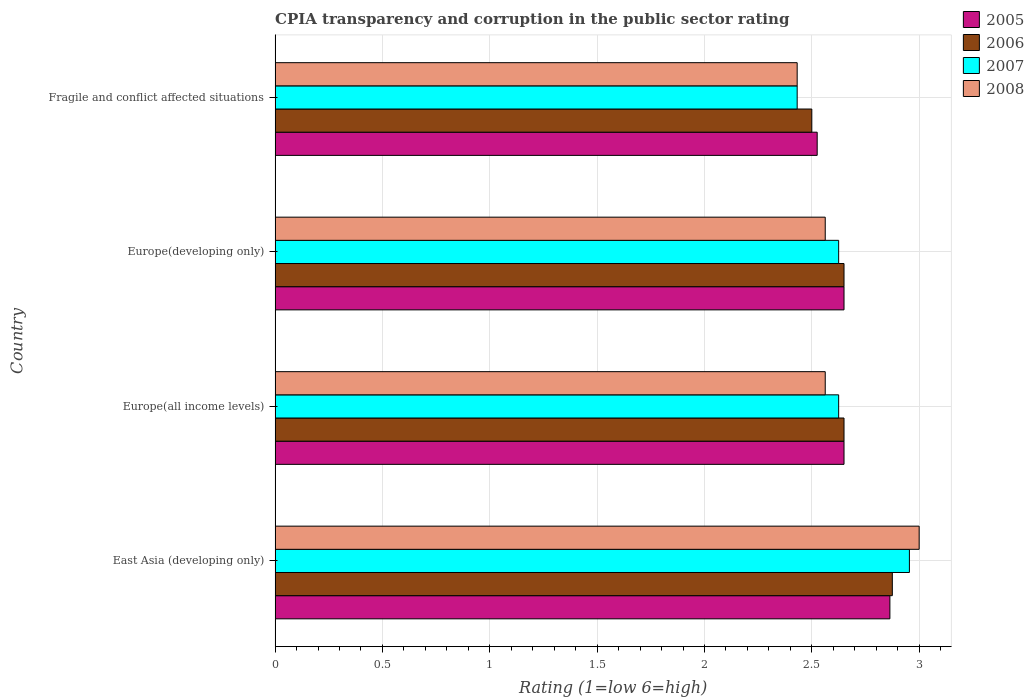How many groups of bars are there?
Ensure brevity in your answer.  4. How many bars are there on the 4th tick from the top?
Make the answer very short. 4. What is the label of the 1st group of bars from the top?
Give a very brief answer. Fragile and conflict affected situations. What is the CPIA rating in 2008 in East Asia (developing only)?
Make the answer very short. 3. Across all countries, what is the maximum CPIA rating in 2006?
Keep it short and to the point. 2.88. Across all countries, what is the minimum CPIA rating in 2007?
Make the answer very short. 2.43. In which country was the CPIA rating in 2008 maximum?
Your response must be concise. East Asia (developing only). In which country was the CPIA rating in 2005 minimum?
Provide a short and direct response. Fragile and conflict affected situations. What is the total CPIA rating in 2006 in the graph?
Provide a succinct answer. 10.68. What is the difference between the CPIA rating in 2008 in Europe(developing only) and that in Fragile and conflict affected situations?
Provide a short and direct response. 0.13. What is the difference between the CPIA rating in 2008 in Europe(developing only) and the CPIA rating in 2005 in East Asia (developing only)?
Provide a short and direct response. -0.3. What is the average CPIA rating in 2006 per country?
Your response must be concise. 2.67. What is the ratio of the CPIA rating in 2007 in Europe(developing only) to that in Fragile and conflict affected situations?
Your answer should be compact. 1.08. Is the CPIA rating in 2005 in Europe(all income levels) less than that in Fragile and conflict affected situations?
Give a very brief answer. No. What is the difference between the highest and the second highest CPIA rating in 2008?
Provide a short and direct response. 0.44. In how many countries, is the CPIA rating in 2006 greater than the average CPIA rating in 2006 taken over all countries?
Your answer should be compact. 1. Is it the case that in every country, the sum of the CPIA rating in 2007 and CPIA rating in 2006 is greater than the sum of CPIA rating in 2005 and CPIA rating in 2008?
Provide a short and direct response. No. What does the 3rd bar from the top in Fragile and conflict affected situations represents?
Provide a succinct answer. 2006. How many bars are there?
Your answer should be compact. 16. How many countries are there in the graph?
Offer a terse response. 4. Are the values on the major ticks of X-axis written in scientific E-notation?
Make the answer very short. No. Does the graph contain grids?
Offer a terse response. Yes. How many legend labels are there?
Your answer should be very brief. 4. How are the legend labels stacked?
Provide a succinct answer. Vertical. What is the title of the graph?
Make the answer very short. CPIA transparency and corruption in the public sector rating. Does "2014" appear as one of the legend labels in the graph?
Your answer should be compact. No. What is the label or title of the X-axis?
Your response must be concise. Rating (1=low 6=high). What is the Rating (1=low 6=high) of 2005 in East Asia (developing only)?
Your answer should be very brief. 2.86. What is the Rating (1=low 6=high) of 2006 in East Asia (developing only)?
Provide a succinct answer. 2.88. What is the Rating (1=low 6=high) in 2007 in East Asia (developing only)?
Your response must be concise. 2.95. What is the Rating (1=low 6=high) of 2008 in East Asia (developing only)?
Ensure brevity in your answer.  3. What is the Rating (1=low 6=high) in 2005 in Europe(all income levels)?
Make the answer very short. 2.65. What is the Rating (1=low 6=high) of 2006 in Europe(all income levels)?
Your answer should be compact. 2.65. What is the Rating (1=low 6=high) of 2007 in Europe(all income levels)?
Your answer should be compact. 2.62. What is the Rating (1=low 6=high) of 2008 in Europe(all income levels)?
Your response must be concise. 2.56. What is the Rating (1=low 6=high) in 2005 in Europe(developing only)?
Give a very brief answer. 2.65. What is the Rating (1=low 6=high) in 2006 in Europe(developing only)?
Provide a succinct answer. 2.65. What is the Rating (1=low 6=high) in 2007 in Europe(developing only)?
Offer a terse response. 2.62. What is the Rating (1=low 6=high) of 2008 in Europe(developing only)?
Your response must be concise. 2.56. What is the Rating (1=low 6=high) in 2005 in Fragile and conflict affected situations?
Offer a very short reply. 2.52. What is the Rating (1=low 6=high) of 2006 in Fragile and conflict affected situations?
Your response must be concise. 2.5. What is the Rating (1=low 6=high) of 2007 in Fragile and conflict affected situations?
Offer a terse response. 2.43. What is the Rating (1=low 6=high) of 2008 in Fragile and conflict affected situations?
Provide a short and direct response. 2.43. Across all countries, what is the maximum Rating (1=low 6=high) in 2005?
Provide a short and direct response. 2.86. Across all countries, what is the maximum Rating (1=low 6=high) in 2006?
Your response must be concise. 2.88. Across all countries, what is the maximum Rating (1=low 6=high) in 2007?
Your response must be concise. 2.95. Across all countries, what is the minimum Rating (1=low 6=high) of 2005?
Provide a succinct answer. 2.52. Across all countries, what is the minimum Rating (1=low 6=high) of 2006?
Offer a very short reply. 2.5. Across all countries, what is the minimum Rating (1=low 6=high) in 2007?
Make the answer very short. 2.43. Across all countries, what is the minimum Rating (1=low 6=high) in 2008?
Provide a short and direct response. 2.43. What is the total Rating (1=low 6=high) of 2005 in the graph?
Your answer should be compact. 10.69. What is the total Rating (1=low 6=high) of 2006 in the graph?
Ensure brevity in your answer.  10.68. What is the total Rating (1=low 6=high) in 2007 in the graph?
Your answer should be compact. 10.64. What is the total Rating (1=low 6=high) of 2008 in the graph?
Make the answer very short. 10.56. What is the difference between the Rating (1=low 6=high) of 2005 in East Asia (developing only) and that in Europe(all income levels)?
Ensure brevity in your answer.  0.21. What is the difference between the Rating (1=low 6=high) of 2006 in East Asia (developing only) and that in Europe(all income levels)?
Keep it short and to the point. 0.23. What is the difference between the Rating (1=low 6=high) in 2007 in East Asia (developing only) and that in Europe(all income levels)?
Your answer should be very brief. 0.33. What is the difference between the Rating (1=low 6=high) in 2008 in East Asia (developing only) and that in Europe(all income levels)?
Your response must be concise. 0.44. What is the difference between the Rating (1=low 6=high) of 2005 in East Asia (developing only) and that in Europe(developing only)?
Provide a succinct answer. 0.21. What is the difference between the Rating (1=low 6=high) of 2006 in East Asia (developing only) and that in Europe(developing only)?
Offer a very short reply. 0.23. What is the difference between the Rating (1=low 6=high) in 2007 in East Asia (developing only) and that in Europe(developing only)?
Provide a succinct answer. 0.33. What is the difference between the Rating (1=low 6=high) of 2008 in East Asia (developing only) and that in Europe(developing only)?
Your response must be concise. 0.44. What is the difference between the Rating (1=low 6=high) of 2005 in East Asia (developing only) and that in Fragile and conflict affected situations?
Make the answer very short. 0.34. What is the difference between the Rating (1=low 6=high) of 2006 in East Asia (developing only) and that in Fragile and conflict affected situations?
Keep it short and to the point. 0.38. What is the difference between the Rating (1=low 6=high) in 2007 in East Asia (developing only) and that in Fragile and conflict affected situations?
Keep it short and to the point. 0.52. What is the difference between the Rating (1=low 6=high) of 2008 in East Asia (developing only) and that in Fragile and conflict affected situations?
Your response must be concise. 0.57. What is the difference between the Rating (1=low 6=high) of 2005 in Europe(all income levels) and that in Europe(developing only)?
Ensure brevity in your answer.  0. What is the difference between the Rating (1=low 6=high) of 2008 in Europe(all income levels) and that in Europe(developing only)?
Make the answer very short. 0. What is the difference between the Rating (1=low 6=high) in 2007 in Europe(all income levels) and that in Fragile and conflict affected situations?
Offer a very short reply. 0.19. What is the difference between the Rating (1=low 6=high) of 2008 in Europe(all income levels) and that in Fragile and conflict affected situations?
Give a very brief answer. 0.13. What is the difference between the Rating (1=low 6=high) in 2007 in Europe(developing only) and that in Fragile and conflict affected situations?
Your response must be concise. 0.19. What is the difference between the Rating (1=low 6=high) in 2008 in Europe(developing only) and that in Fragile and conflict affected situations?
Provide a succinct answer. 0.13. What is the difference between the Rating (1=low 6=high) of 2005 in East Asia (developing only) and the Rating (1=low 6=high) of 2006 in Europe(all income levels)?
Provide a short and direct response. 0.21. What is the difference between the Rating (1=low 6=high) of 2005 in East Asia (developing only) and the Rating (1=low 6=high) of 2007 in Europe(all income levels)?
Give a very brief answer. 0.24. What is the difference between the Rating (1=low 6=high) of 2005 in East Asia (developing only) and the Rating (1=low 6=high) of 2008 in Europe(all income levels)?
Provide a succinct answer. 0.3. What is the difference between the Rating (1=low 6=high) of 2006 in East Asia (developing only) and the Rating (1=low 6=high) of 2008 in Europe(all income levels)?
Your response must be concise. 0.31. What is the difference between the Rating (1=low 6=high) in 2007 in East Asia (developing only) and the Rating (1=low 6=high) in 2008 in Europe(all income levels)?
Give a very brief answer. 0.39. What is the difference between the Rating (1=low 6=high) of 2005 in East Asia (developing only) and the Rating (1=low 6=high) of 2006 in Europe(developing only)?
Your answer should be very brief. 0.21. What is the difference between the Rating (1=low 6=high) of 2005 in East Asia (developing only) and the Rating (1=low 6=high) of 2007 in Europe(developing only)?
Your response must be concise. 0.24. What is the difference between the Rating (1=low 6=high) in 2005 in East Asia (developing only) and the Rating (1=low 6=high) in 2008 in Europe(developing only)?
Make the answer very short. 0.3. What is the difference between the Rating (1=low 6=high) of 2006 in East Asia (developing only) and the Rating (1=low 6=high) of 2008 in Europe(developing only)?
Offer a terse response. 0.31. What is the difference between the Rating (1=low 6=high) of 2007 in East Asia (developing only) and the Rating (1=low 6=high) of 2008 in Europe(developing only)?
Your response must be concise. 0.39. What is the difference between the Rating (1=low 6=high) in 2005 in East Asia (developing only) and the Rating (1=low 6=high) in 2006 in Fragile and conflict affected situations?
Your answer should be very brief. 0.36. What is the difference between the Rating (1=low 6=high) of 2005 in East Asia (developing only) and the Rating (1=low 6=high) of 2007 in Fragile and conflict affected situations?
Keep it short and to the point. 0.43. What is the difference between the Rating (1=low 6=high) of 2005 in East Asia (developing only) and the Rating (1=low 6=high) of 2008 in Fragile and conflict affected situations?
Your answer should be very brief. 0.43. What is the difference between the Rating (1=low 6=high) in 2006 in East Asia (developing only) and the Rating (1=low 6=high) in 2007 in Fragile and conflict affected situations?
Provide a succinct answer. 0.44. What is the difference between the Rating (1=low 6=high) of 2006 in East Asia (developing only) and the Rating (1=low 6=high) of 2008 in Fragile and conflict affected situations?
Provide a short and direct response. 0.44. What is the difference between the Rating (1=low 6=high) of 2007 in East Asia (developing only) and the Rating (1=low 6=high) of 2008 in Fragile and conflict affected situations?
Your answer should be very brief. 0.52. What is the difference between the Rating (1=low 6=high) in 2005 in Europe(all income levels) and the Rating (1=low 6=high) in 2007 in Europe(developing only)?
Your answer should be compact. 0.03. What is the difference between the Rating (1=low 6=high) of 2005 in Europe(all income levels) and the Rating (1=low 6=high) of 2008 in Europe(developing only)?
Your answer should be compact. 0.09. What is the difference between the Rating (1=low 6=high) in 2006 in Europe(all income levels) and the Rating (1=low 6=high) in 2007 in Europe(developing only)?
Offer a terse response. 0.03. What is the difference between the Rating (1=low 6=high) of 2006 in Europe(all income levels) and the Rating (1=low 6=high) of 2008 in Europe(developing only)?
Keep it short and to the point. 0.09. What is the difference between the Rating (1=low 6=high) in 2007 in Europe(all income levels) and the Rating (1=low 6=high) in 2008 in Europe(developing only)?
Your response must be concise. 0.06. What is the difference between the Rating (1=low 6=high) in 2005 in Europe(all income levels) and the Rating (1=low 6=high) in 2006 in Fragile and conflict affected situations?
Offer a terse response. 0.15. What is the difference between the Rating (1=low 6=high) in 2005 in Europe(all income levels) and the Rating (1=low 6=high) in 2007 in Fragile and conflict affected situations?
Provide a short and direct response. 0.22. What is the difference between the Rating (1=low 6=high) in 2005 in Europe(all income levels) and the Rating (1=low 6=high) in 2008 in Fragile and conflict affected situations?
Give a very brief answer. 0.22. What is the difference between the Rating (1=low 6=high) in 2006 in Europe(all income levels) and the Rating (1=low 6=high) in 2007 in Fragile and conflict affected situations?
Offer a terse response. 0.22. What is the difference between the Rating (1=low 6=high) in 2006 in Europe(all income levels) and the Rating (1=low 6=high) in 2008 in Fragile and conflict affected situations?
Your answer should be compact. 0.22. What is the difference between the Rating (1=low 6=high) of 2007 in Europe(all income levels) and the Rating (1=low 6=high) of 2008 in Fragile and conflict affected situations?
Your answer should be compact. 0.19. What is the difference between the Rating (1=low 6=high) in 2005 in Europe(developing only) and the Rating (1=low 6=high) in 2006 in Fragile and conflict affected situations?
Your answer should be compact. 0.15. What is the difference between the Rating (1=low 6=high) of 2005 in Europe(developing only) and the Rating (1=low 6=high) of 2007 in Fragile and conflict affected situations?
Ensure brevity in your answer.  0.22. What is the difference between the Rating (1=low 6=high) of 2005 in Europe(developing only) and the Rating (1=low 6=high) of 2008 in Fragile and conflict affected situations?
Provide a succinct answer. 0.22. What is the difference between the Rating (1=low 6=high) in 2006 in Europe(developing only) and the Rating (1=low 6=high) in 2007 in Fragile and conflict affected situations?
Ensure brevity in your answer.  0.22. What is the difference between the Rating (1=low 6=high) of 2006 in Europe(developing only) and the Rating (1=low 6=high) of 2008 in Fragile and conflict affected situations?
Give a very brief answer. 0.22. What is the difference between the Rating (1=low 6=high) in 2007 in Europe(developing only) and the Rating (1=low 6=high) in 2008 in Fragile and conflict affected situations?
Your answer should be very brief. 0.19. What is the average Rating (1=low 6=high) of 2005 per country?
Provide a short and direct response. 2.67. What is the average Rating (1=low 6=high) in 2006 per country?
Offer a very short reply. 2.67. What is the average Rating (1=low 6=high) of 2007 per country?
Offer a terse response. 2.66. What is the average Rating (1=low 6=high) of 2008 per country?
Provide a succinct answer. 2.64. What is the difference between the Rating (1=low 6=high) in 2005 and Rating (1=low 6=high) in 2006 in East Asia (developing only)?
Ensure brevity in your answer.  -0.01. What is the difference between the Rating (1=low 6=high) in 2005 and Rating (1=low 6=high) in 2007 in East Asia (developing only)?
Your response must be concise. -0.09. What is the difference between the Rating (1=low 6=high) in 2005 and Rating (1=low 6=high) in 2008 in East Asia (developing only)?
Make the answer very short. -0.14. What is the difference between the Rating (1=low 6=high) in 2006 and Rating (1=low 6=high) in 2007 in East Asia (developing only)?
Make the answer very short. -0.08. What is the difference between the Rating (1=low 6=high) of 2006 and Rating (1=low 6=high) of 2008 in East Asia (developing only)?
Offer a terse response. -0.12. What is the difference between the Rating (1=low 6=high) in 2007 and Rating (1=low 6=high) in 2008 in East Asia (developing only)?
Offer a terse response. -0.05. What is the difference between the Rating (1=low 6=high) in 2005 and Rating (1=low 6=high) in 2006 in Europe(all income levels)?
Offer a terse response. 0. What is the difference between the Rating (1=low 6=high) of 2005 and Rating (1=low 6=high) of 2007 in Europe(all income levels)?
Offer a very short reply. 0.03. What is the difference between the Rating (1=low 6=high) in 2005 and Rating (1=low 6=high) in 2008 in Europe(all income levels)?
Provide a short and direct response. 0.09. What is the difference between the Rating (1=low 6=high) of 2006 and Rating (1=low 6=high) of 2007 in Europe(all income levels)?
Provide a short and direct response. 0.03. What is the difference between the Rating (1=low 6=high) of 2006 and Rating (1=low 6=high) of 2008 in Europe(all income levels)?
Provide a succinct answer. 0.09. What is the difference between the Rating (1=low 6=high) in 2007 and Rating (1=low 6=high) in 2008 in Europe(all income levels)?
Your answer should be very brief. 0.06. What is the difference between the Rating (1=low 6=high) in 2005 and Rating (1=low 6=high) in 2007 in Europe(developing only)?
Offer a very short reply. 0.03. What is the difference between the Rating (1=low 6=high) of 2005 and Rating (1=low 6=high) of 2008 in Europe(developing only)?
Ensure brevity in your answer.  0.09. What is the difference between the Rating (1=low 6=high) of 2006 and Rating (1=low 6=high) of 2007 in Europe(developing only)?
Your response must be concise. 0.03. What is the difference between the Rating (1=low 6=high) of 2006 and Rating (1=low 6=high) of 2008 in Europe(developing only)?
Offer a very short reply. 0.09. What is the difference between the Rating (1=low 6=high) in 2007 and Rating (1=low 6=high) in 2008 in Europe(developing only)?
Make the answer very short. 0.06. What is the difference between the Rating (1=low 6=high) in 2005 and Rating (1=low 6=high) in 2006 in Fragile and conflict affected situations?
Ensure brevity in your answer.  0.03. What is the difference between the Rating (1=low 6=high) of 2005 and Rating (1=low 6=high) of 2007 in Fragile and conflict affected situations?
Offer a terse response. 0.09. What is the difference between the Rating (1=low 6=high) in 2005 and Rating (1=low 6=high) in 2008 in Fragile and conflict affected situations?
Provide a short and direct response. 0.09. What is the difference between the Rating (1=low 6=high) in 2006 and Rating (1=low 6=high) in 2007 in Fragile and conflict affected situations?
Give a very brief answer. 0.07. What is the difference between the Rating (1=low 6=high) of 2006 and Rating (1=low 6=high) of 2008 in Fragile and conflict affected situations?
Make the answer very short. 0.07. What is the difference between the Rating (1=low 6=high) of 2007 and Rating (1=low 6=high) of 2008 in Fragile and conflict affected situations?
Keep it short and to the point. 0. What is the ratio of the Rating (1=low 6=high) in 2005 in East Asia (developing only) to that in Europe(all income levels)?
Make the answer very short. 1.08. What is the ratio of the Rating (1=low 6=high) in 2006 in East Asia (developing only) to that in Europe(all income levels)?
Offer a very short reply. 1.08. What is the ratio of the Rating (1=low 6=high) of 2007 in East Asia (developing only) to that in Europe(all income levels)?
Your answer should be compact. 1.13. What is the ratio of the Rating (1=low 6=high) of 2008 in East Asia (developing only) to that in Europe(all income levels)?
Your response must be concise. 1.17. What is the ratio of the Rating (1=low 6=high) in 2005 in East Asia (developing only) to that in Europe(developing only)?
Make the answer very short. 1.08. What is the ratio of the Rating (1=low 6=high) of 2006 in East Asia (developing only) to that in Europe(developing only)?
Keep it short and to the point. 1.08. What is the ratio of the Rating (1=low 6=high) in 2007 in East Asia (developing only) to that in Europe(developing only)?
Make the answer very short. 1.13. What is the ratio of the Rating (1=low 6=high) of 2008 in East Asia (developing only) to that in Europe(developing only)?
Ensure brevity in your answer.  1.17. What is the ratio of the Rating (1=low 6=high) in 2005 in East Asia (developing only) to that in Fragile and conflict affected situations?
Offer a terse response. 1.13. What is the ratio of the Rating (1=low 6=high) of 2006 in East Asia (developing only) to that in Fragile and conflict affected situations?
Offer a very short reply. 1.15. What is the ratio of the Rating (1=low 6=high) in 2007 in East Asia (developing only) to that in Fragile and conflict affected situations?
Offer a terse response. 1.22. What is the ratio of the Rating (1=low 6=high) of 2008 in East Asia (developing only) to that in Fragile and conflict affected situations?
Keep it short and to the point. 1.23. What is the ratio of the Rating (1=low 6=high) in 2005 in Europe(all income levels) to that in Fragile and conflict affected situations?
Provide a succinct answer. 1.05. What is the ratio of the Rating (1=low 6=high) in 2006 in Europe(all income levels) to that in Fragile and conflict affected situations?
Your answer should be compact. 1.06. What is the ratio of the Rating (1=low 6=high) of 2007 in Europe(all income levels) to that in Fragile and conflict affected situations?
Give a very brief answer. 1.08. What is the ratio of the Rating (1=low 6=high) of 2008 in Europe(all income levels) to that in Fragile and conflict affected situations?
Ensure brevity in your answer.  1.05. What is the ratio of the Rating (1=low 6=high) of 2005 in Europe(developing only) to that in Fragile and conflict affected situations?
Make the answer very short. 1.05. What is the ratio of the Rating (1=low 6=high) of 2006 in Europe(developing only) to that in Fragile and conflict affected situations?
Your response must be concise. 1.06. What is the ratio of the Rating (1=low 6=high) in 2007 in Europe(developing only) to that in Fragile and conflict affected situations?
Offer a terse response. 1.08. What is the ratio of the Rating (1=low 6=high) in 2008 in Europe(developing only) to that in Fragile and conflict affected situations?
Make the answer very short. 1.05. What is the difference between the highest and the second highest Rating (1=low 6=high) of 2005?
Provide a short and direct response. 0.21. What is the difference between the highest and the second highest Rating (1=low 6=high) in 2006?
Make the answer very short. 0.23. What is the difference between the highest and the second highest Rating (1=low 6=high) in 2007?
Offer a terse response. 0.33. What is the difference between the highest and the second highest Rating (1=low 6=high) of 2008?
Make the answer very short. 0.44. What is the difference between the highest and the lowest Rating (1=low 6=high) in 2005?
Offer a very short reply. 0.34. What is the difference between the highest and the lowest Rating (1=low 6=high) in 2006?
Offer a terse response. 0.38. What is the difference between the highest and the lowest Rating (1=low 6=high) in 2007?
Offer a terse response. 0.52. What is the difference between the highest and the lowest Rating (1=low 6=high) in 2008?
Give a very brief answer. 0.57. 